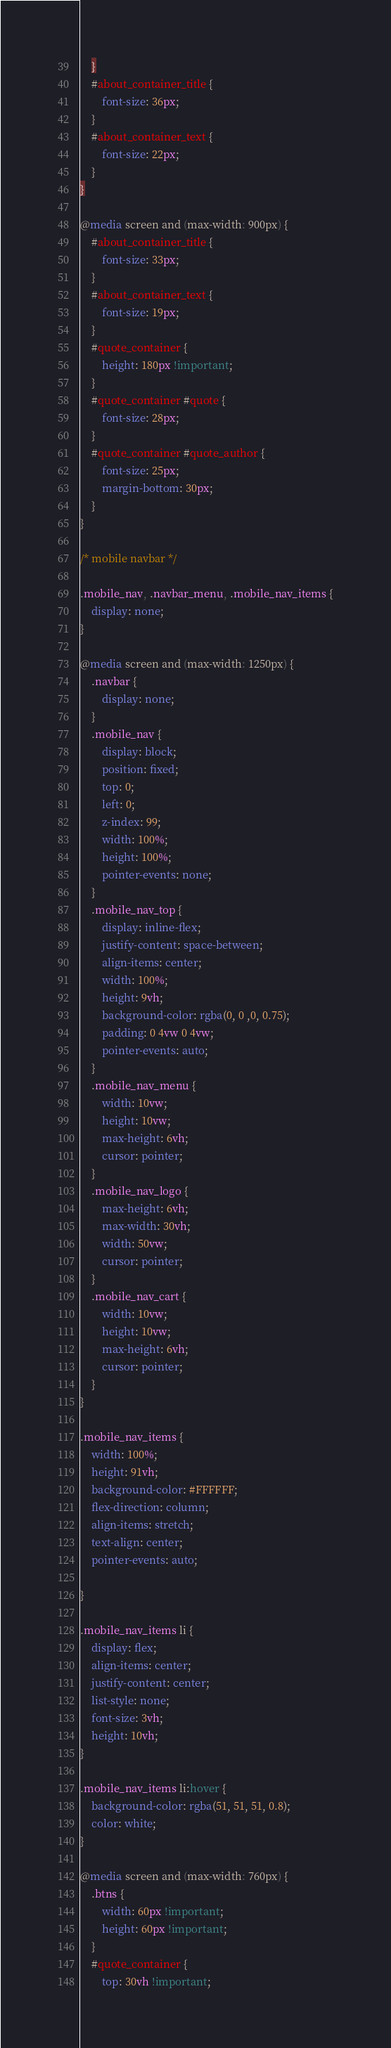<code> <loc_0><loc_0><loc_500><loc_500><_CSS_>    }
    #about_container_title {
        font-size: 36px;
    }
    #about_container_text {
        font-size: 22px;
    }
}

@media screen and (max-width: 900px) {
    #about_container_title {
        font-size: 33px;
    }
    #about_container_text {
        font-size: 19px;
    }
    #quote_container {
        height: 180px !important;
    }
    #quote_container #quote {
        font-size: 28px;
    }
    #quote_container #quote_author {
        font-size: 25px;
        margin-bottom: 30px;
    }
}

/* mobile navbar */

.mobile_nav, .navbar_menu, .mobile_nav_items {
    display: none;
}

@media screen and (max-width: 1250px) {
    .navbar {
        display: none;
    }
    .mobile_nav {
        display: block;
        position: fixed;
        top: 0;
        left: 0;
        z-index: 99;
        width: 100%;
        height: 100%;
        pointer-events: none;
    }
    .mobile_nav_top {
        display: inline-flex;
        justify-content: space-between;
        align-items: center;
        width: 100%;
        height: 9vh;
        background-color: rgba(0, 0 ,0, 0.75);
        padding: 0 4vw 0 4vw;
        pointer-events: auto;
    }
    .mobile_nav_menu {
        width: 10vw;
        height: 10vw;
        max-height: 6vh;
        cursor: pointer;
    }
    .mobile_nav_logo {
        max-height: 6vh;
        max-width: 30vh;
        width: 50vw;
        cursor: pointer;
    }
    .mobile_nav_cart {
        width: 10vw;
        height: 10vw;
        max-height: 6vh;
        cursor: pointer;
    }
}

.mobile_nav_items {
    width: 100%;
    height: 91vh;
    background-color: #FFFFFF;
    flex-direction: column;
    align-items: stretch;
    text-align: center;
    pointer-events: auto;

}

.mobile_nav_items li {
    display: flex;
    align-items: center;
    justify-content: center;
    list-style: none;
    font-size: 3vh;
    height: 10vh;
}

.mobile_nav_items li:hover {
    background-color: rgba(51, 51, 51, 0.8);
    color: white;
}

@media screen and (max-width: 760px) {
    .btns {
        width: 60px !important;
        height: 60px !important;
    }
    #quote_container {
        top: 30vh !important;</code> 